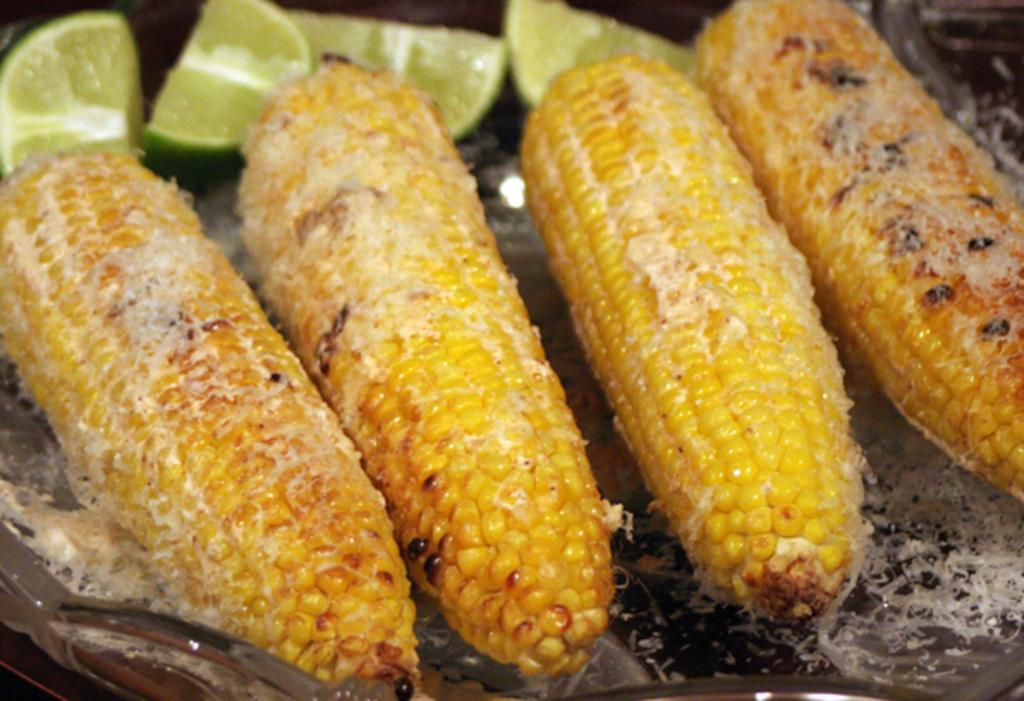What is the main object in the center of the image? There is a glass object in the center of the image. What is inside the glass object? The glass object contains corn and lemon slices. What type of food items can be seen in the glass object? The glass object contains some food items, including corn and lemon slices. Can you see a knot tied in the corn inside the glass object? There is no knot present in the image, as it features a glass object containing corn and lemon slices. 